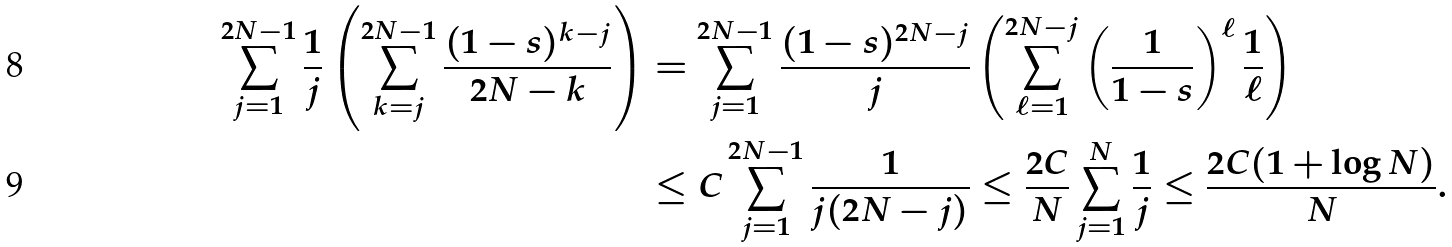Convert formula to latex. <formula><loc_0><loc_0><loc_500><loc_500>\sum _ { j = 1 } ^ { 2 N - 1 } \frac { 1 } { j } \left ( \sum _ { k = j } ^ { 2 N - 1 } \frac { ( 1 - s ) ^ { k - j } } { 2 N - k } \right ) & = \sum _ { j = 1 } ^ { 2 N - 1 } \frac { ( 1 - s ) ^ { 2 N - j } } { j } \left ( \sum _ { \ell = 1 } ^ { 2 N - j } \left ( \frac { 1 } { 1 - s } \right ) ^ { \ell } \frac { 1 } { \ell } \right ) \\ & \leq C \sum _ { j = 1 } ^ { 2 N - 1 } \frac { 1 } { j ( 2 N - j ) } \leq \frac { 2 C } { N } \sum _ { j = 1 } ^ { N } \frac { 1 } { j } \leq \frac { 2 C ( 1 + \log N ) } { N } .</formula> 